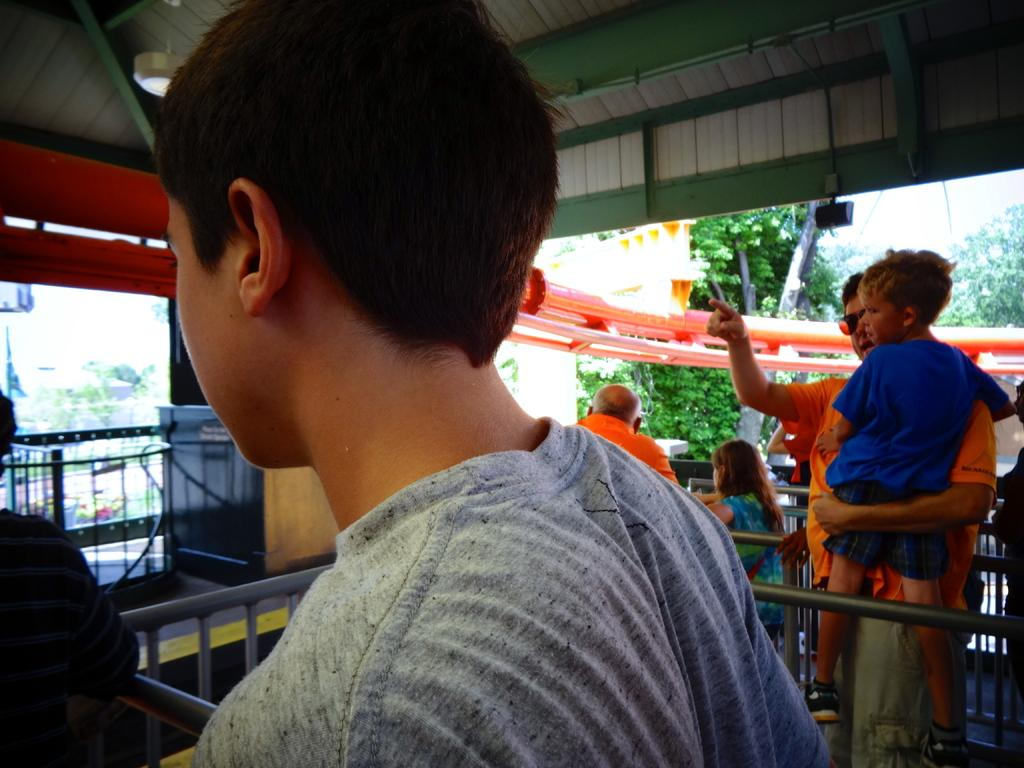What is happening in the front of the image? There are persons standing in the front of the image. What are the persons doing or standing near? The persons are on either side of a grill. Where is the grill located? The grill is under a roof. What can be seen in the background of the image? There are trees in the background of the image. Can you see a shelf in the image? There is no shelf present in the image. What type of tongue is visible in the image? There is no tongue visible in the image. 